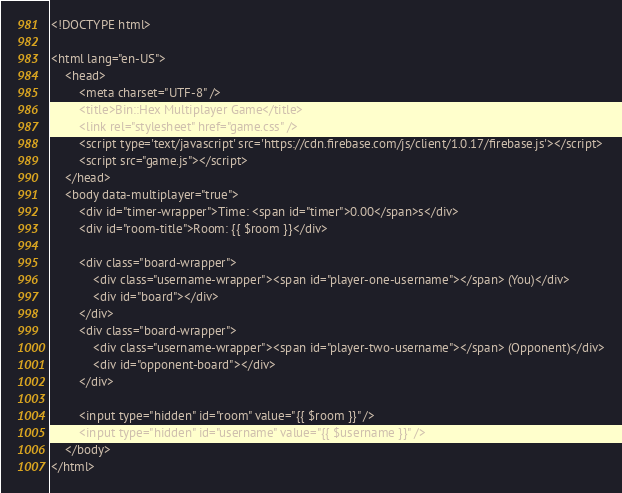Convert code to text. <code><loc_0><loc_0><loc_500><loc_500><_PHP_><!DOCTYPE html>

<html lang="en-US">
    <head>
        <meta charset="UTF-8" />
        <title>Bin::Hex Multiplayer Game</title>
        <link rel="stylesheet" href="game.css" />
        <script type='text/javascript' src='https://cdn.firebase.com/js/client/1.0.17/firebase.js'></script>
        <script src="game.js"></script>
    </head>
    <body data-multiplayer="true">
        <div id="timer-wrapper">Time: <span id="timer">0.00</span>s</div>
        <div id="room-title">Room: {{ $room }}</div>

        <div class="board-wrapper">
            <div class="username-wrapper"><span id="player-one-username"></span> (You)</div>
            <div id="board"></div>
        </div>
        <div class="board-wrapper">
            <div class="username-wrapper"><span id="player-two-username"></span> (Opponent)</div>
            <div id="opponent-board"></div>
        </div>

        <input type="hidden" id="room" value="{{ $room }}" />
        <input type="hidden" id="username" value="{{ $username }}" />
    </body>
</html></code> 